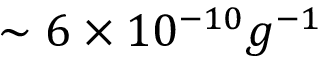Convert formula to latex. <formula><loc_0><loc_0><loc_500><loc_500>\sim 6 \times 1 0 ^ { - 1 0 } g ^ { - 1 }</formula> 